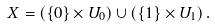<formula> <loc_0><loc_0><loc_500><loc_500>X = \left ( \{ 0 \} \times U _ { 0 } \right ) \cup \left ( \{ 1 \} \times U _ { 1 } \right ) .</formula> 